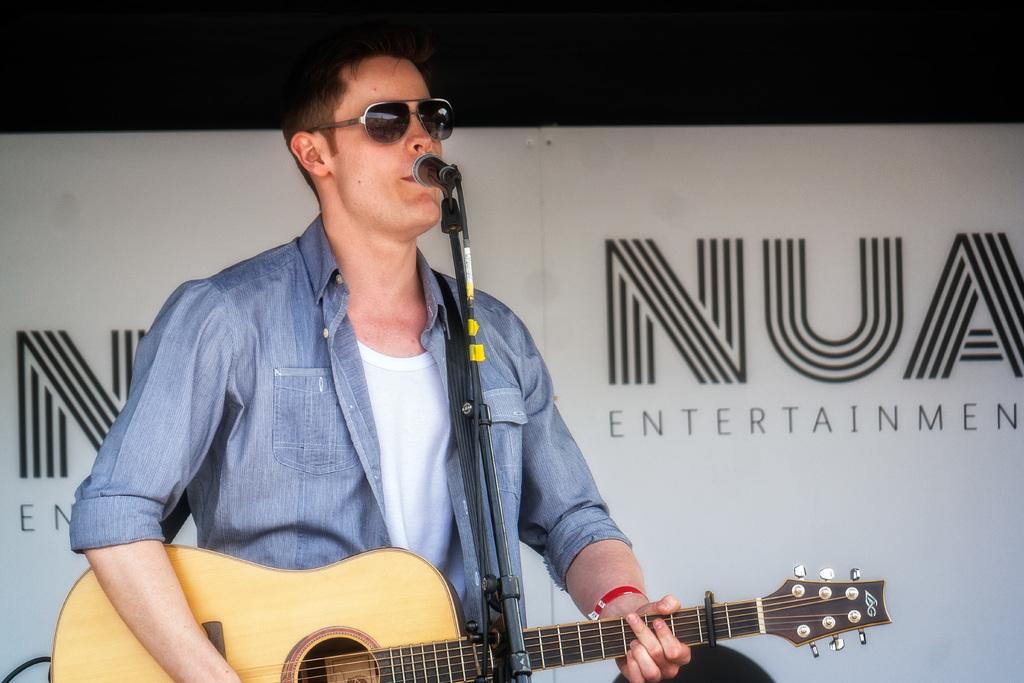In one or two sentences, can you explain what this image depicts? In this picture we can see a man who is playing guitar. This is the mike and he has goggles. 